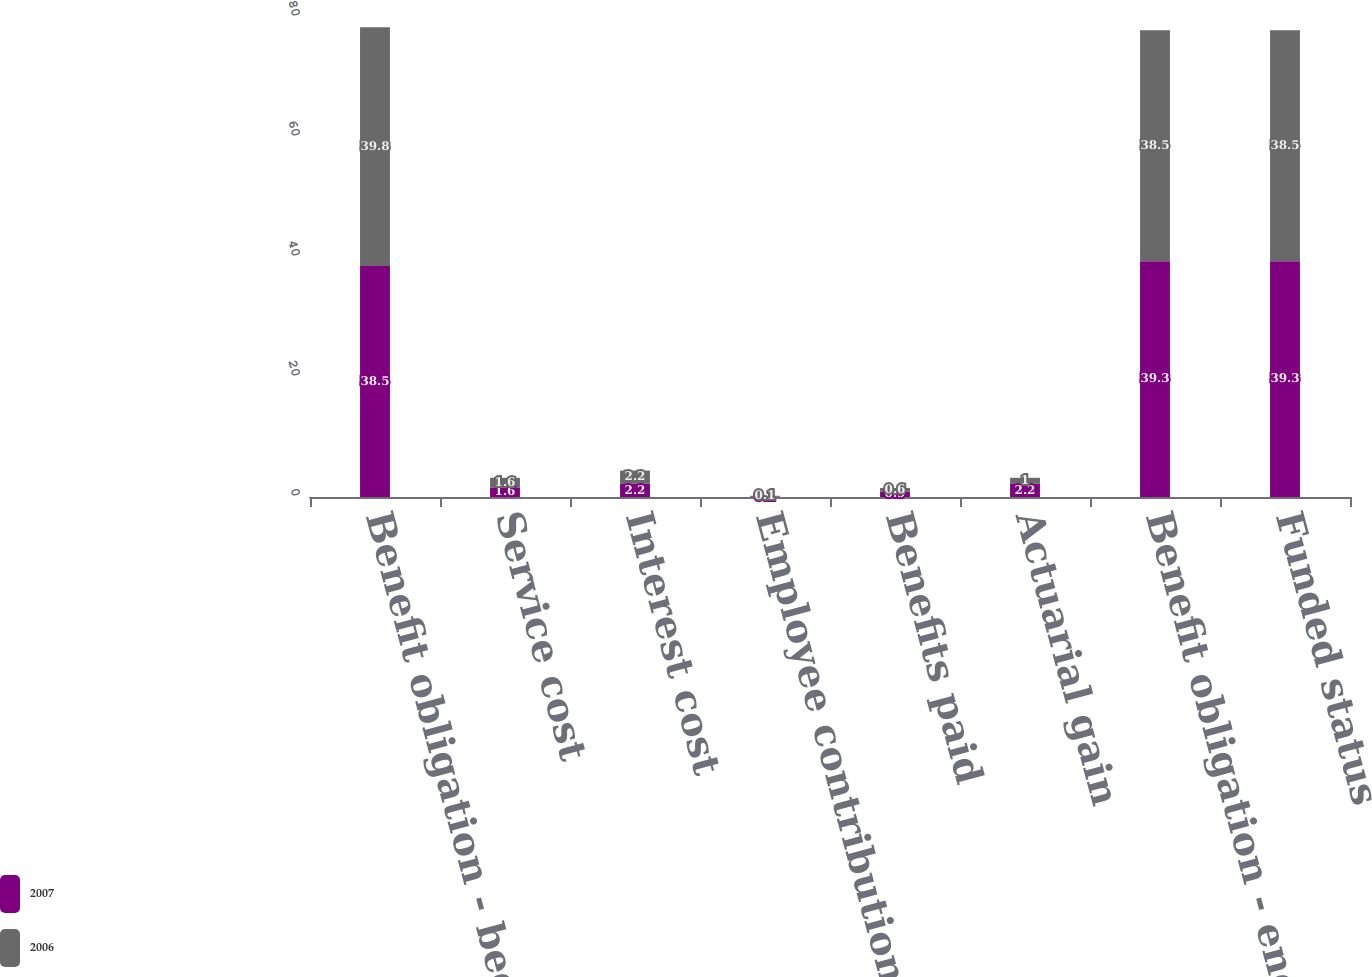Convert chart. <chart><loc_0><loc_0><loc_500><loc_500><stacked_bar_chart><ecel><fcel>Benefit obligation - beginning<fcel>Service cost<fcel>Interest cost<fcel>Employee contributions<fcel>Benefits paid<fcel>Actuarial gain<fcel>Benefit obligation - end of<fcel>Funded status<nl><fcel>2007<fcel>38.5<fcel>1.6<fcel>2.2<fcel>0.1<fcel>0.9<fcel>2.2<fcel>39.3<fcel>39.3<nl><fcel>2006<fcel>39.8<fcel>1.6<fcel>2.2<fcel>0.1<fcel>0.6<fcel>1<fcel>38.5<fcel>38.5<nl></chart> 